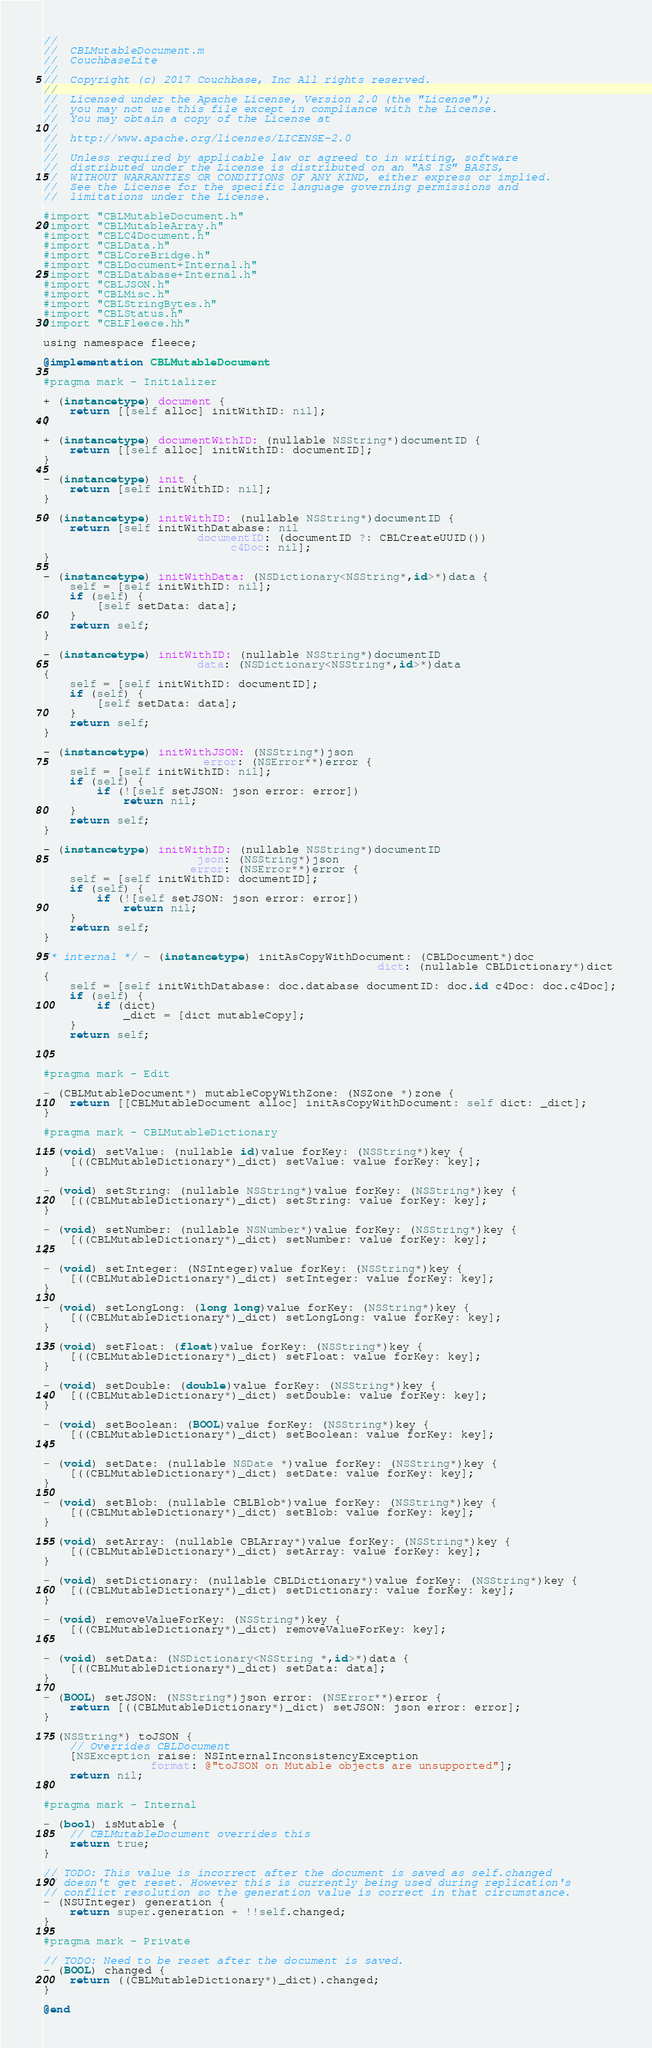Convert code to text. <code><loc_0><loc_0><loc_500><loc_500><_ObjectiveC_>//
//  CBLMutableDocument.m
//  CouchbaseLite
//
//  Copyright (c) 2017 Couchbase, Inc All rights reserved.
//
//  Licensed under the Apache License, Version 2.0 (the "License");
//  you may not use this file except in compliance with the License.
//  You may obtain a copy of the License at
//
//  http://www.apache.org/licenses/LICENSE-2.0
//
//  Unless required by applicable law or agreed to in writing, software
//  distributed under the License is distributed on an "AS IS" BASIS,
//  WITHOUT WARRANTIES OR CONDITIONS OF ANY KIND, either express or implied.
//  See the License for the specific language governing permissions and
//  limitations under the License.

#import "CBLMutableDocument.h"
#import "CBLMutableArray.h"
#import "CBLC4Document.h"
#import "CBLData.h"
#import "CBLCoreBridge.h"
#import "CBLDocument+Internal.h"
#import "CBLDatabase+Internal.h"
#import "CBLJSON.h"
#import "CBLMisc.h"
#import "CBLStringBytes.h"
#import "CBLStatus.h"
#import "CBLFleece.hh"

using namespace fleece;

@implementation CBLMutableDocument

#pragma mark - Initializer

+ (instancetype) document {
    return [[self alloc] initWithID: nil];
}

+ (instancetype) documentWithID: (nullable NSString*)documentID {
    return [[self alloc] initWithID: documentID];
}

- (instancetype) init {
    return [self initWithID: nil];
}

- (instancetype) initWithID: (nullable NSString*)documentID {
    return [self initWithDatabase: nil
                       documentID: (documentID ?: CBLCreateUUID())
                            c4Doc: nil];
}

- (instancetype) initWithData: (NSDictionary<NSString*,id>*)data {
    self = [self initWithID: nil];
    if (self) {
        [self setData: data];
    }
    return self;
}

- (instancetype) initWithID: (nullable NSString*)documentID
                       data: (NSDictionary<NSString*,id>*)data
{
    self = [self initWithID: documentID];
    if (self) {
        [self setData: data];
    }
    return self;
}

- (instancetype) initWithJSON: (NSString*)json
                        error: (NSError**)error {
    self = [self initWithID: nil];
    if (self) {
        if (![self setJSON: json error: error])
            return nil;
    }
    return self;
}

- (instancetype) initWithID: (nullable NSString*)documentID
                       json: (NSString*)json
                      error: (NSError**)error {
    self = [self initWithID: documentID];
    if (self) {
        if (![self setJSON: json error: error])
            return nil;
    }
    return self;
}

/* internal */ - (instancetype) initAsCopyWithDocument: (CBLDocument*)doc
                                                  dict: (nullable CBLDictionary*)dict
{
    self = [self initWithDatabase: doc.database documentID: doc.id c4Doc: doc.c4Doc];
    if (self) {
        if (dict)
            _dict = [dict mutableCopy];
    }
    return self;
    
}

#pragma mark - Edit

- (CBLMutableDocument*) mutableCopyWithZone: (NSZone *)zone {
    return [[CBLMutableDocument alloc] initAsCopyWithDocument: self dict: _dict];
}

#pragma mark - CBLMutableDictionary

- (void) setValue: (nullable id)value forKey: (NSString*)key {
    [((CBLMutableDictionary*)_dict) setValue: value forKey: key];
}

- (void) setString: (nullable NSString*)value forKey: (NSString*)key {
    [((CBLMutableDictionary*)_dict) setString: value forKey: key];
}

- (void) setNumber: (nullable NSNumber*)value forKey: (NSString*)key {
    [((CBLMutableDictionary*)_dict) setNumber: value forKey: key];
}

- (void) setInteger: (NSInteger)value forKey: (NSString*)key {
    [((CBLMutableDictionary*)_dict) setInteger: value forKey: key];
}

- (void) setLongLong: (long long)value forKey: (NSString*)key {
    [((CBLMutableDictionary*)_dict) setLongLong: value forKey: key];
}

- (void) setFloat: (float)value forKey: (NSString*)key {
    [((CBLMutableDictionary*)_dict) setFloat: value forKey: key];
}

- (void) setDouble: (double)value forKey: (NSString*)key {
    [((CBLMutableDictionary*)_dict) setDouble: value forKey: key];
}

- (void) setBoolean: (BOOL)value forKey: (NSString*)key {
    [((CBLMutableDictionary*)_dict) setBoolean: value forKey: key];
}

- (void) setDate: (nullable NSDate *)value forKey: (NSString*)key {
    [((CBLMutableDictionary*)_dict) setDate: value forKey: key];
}

- (void) setBlob: (nullable CBLBlob*)value forKey: (NSString*)key {
    [((CBLMutableDictionary*)_dict) setBlob: value forKey: key];
}

- (void) setArray: (nullable CBLArray*)value forKey: (NSString*)key {
    [((CBLMutableDictionary*)_dict) setArray: value forKey: key];
}

- (void) setDictionary: (nullable CBLDictionary*)value forKey: (NSString*)key {
    [((CBLMutableDictionary*)_dict) setDictionary: value forKey: key];
}

- (void) removeValueForKey: (NSString*)key {
    [((CBLMutableDictionary*)_dict) removeValueForKey: key];
}

- (void) setData: (NSDictionary<NSString *,id>*)data {
    [((CBLMutableDictionary*)_dict) setData: data];
}

- (BOOL) setJSON: (NSString*)json error: (NSError**)error {
    return [((CBLMutableDictionary*)_dict) setJSON: json error: error];
}

- (NSString*) toJSON {
    // Overrides CBLDocument
    [NSException raise: NSInternalInconsistencyException
                format: @"toJSON on Mutable objects are unsupported"];
    return nil;
}

#pragma mark - Internal

- (bool) isMutable {
    // CBLMutableDocument overrides this
    return true;
}

// TODO: This value is incorrect after the document is saved as self.changed
// doesn't get reset. However this is currently being used during replication's
// conflict resolution so the generation value is correct in that circumstance.
- (NSUInteger) generation {
    return super.generation + !!self.changed;
}

#pragma mark - Private

// TODO: Need to be reset after the document is saved.
- (BOOL) changed {
    return ((CBLMutableDictionary*)_dict).changed;
}

@end
</code> 